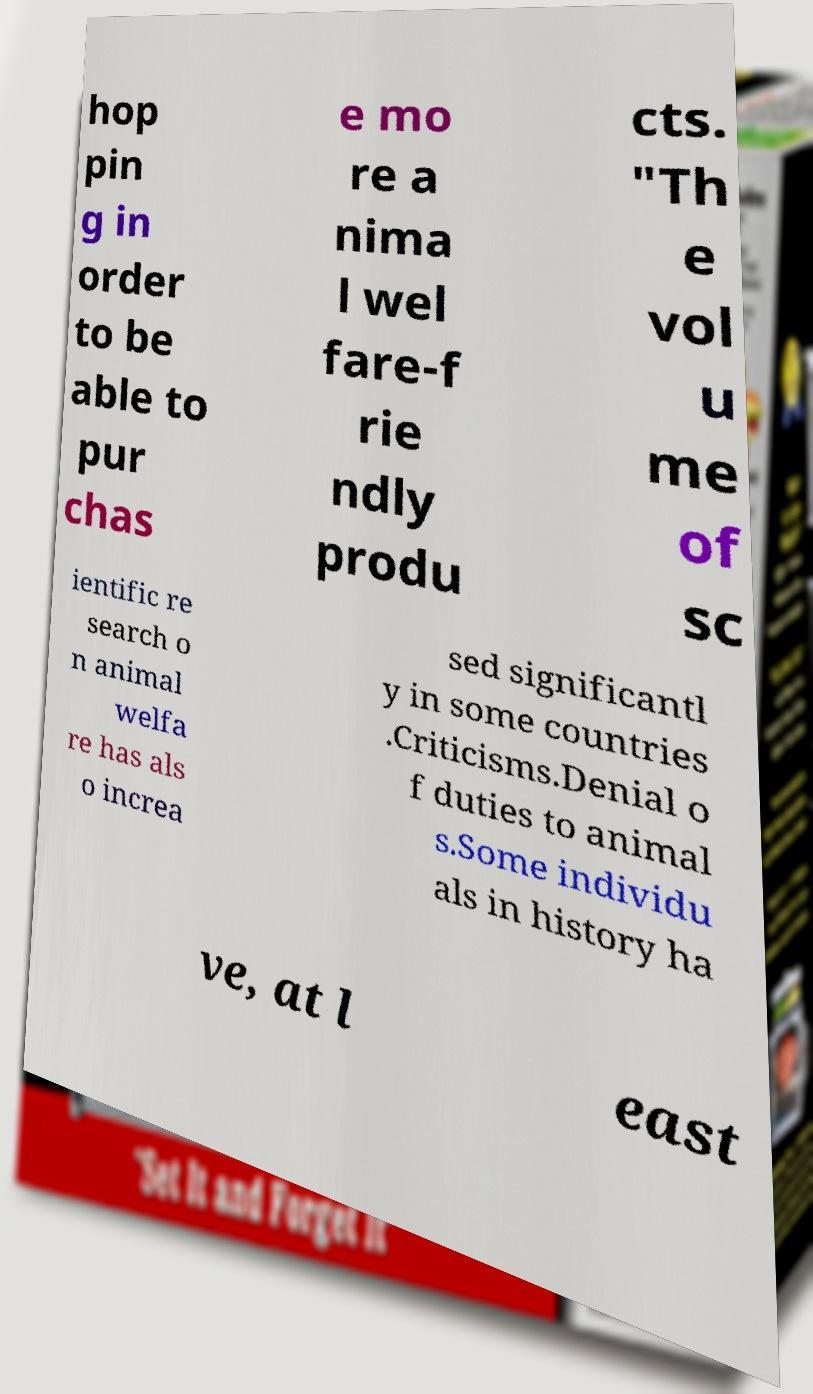There's text embedded in this image that I need extracted. Can you transcribe it verbatim? hop pin g in order to be able to pur chas e mo re a nima l wel fare-f rie ndly produ cts. "Th e vol u me of sc ientific re search o n animal welfa re has als o increa sed significantl y in some countries .Criticisms.Denial o f duties to animal s.Some individu als in history ha ve, at l east 